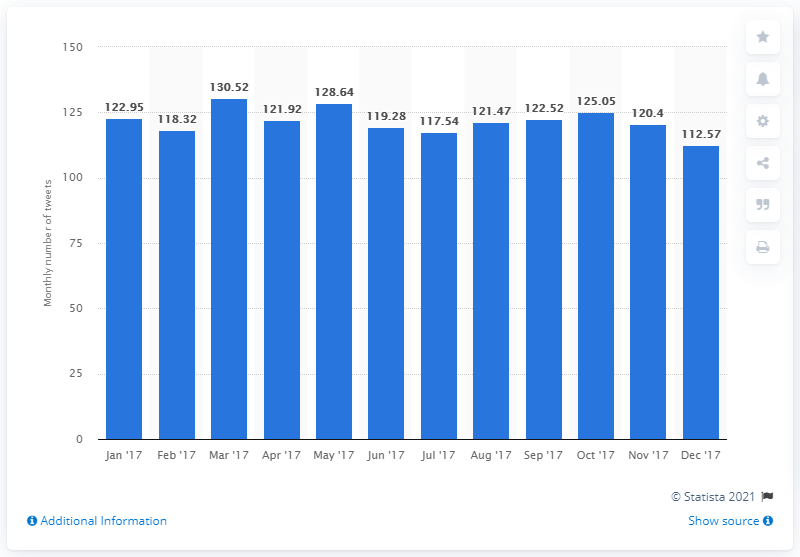Give some essential details in this illustration. In the previous month, the average number of tweets on Twitter was 120.4. 